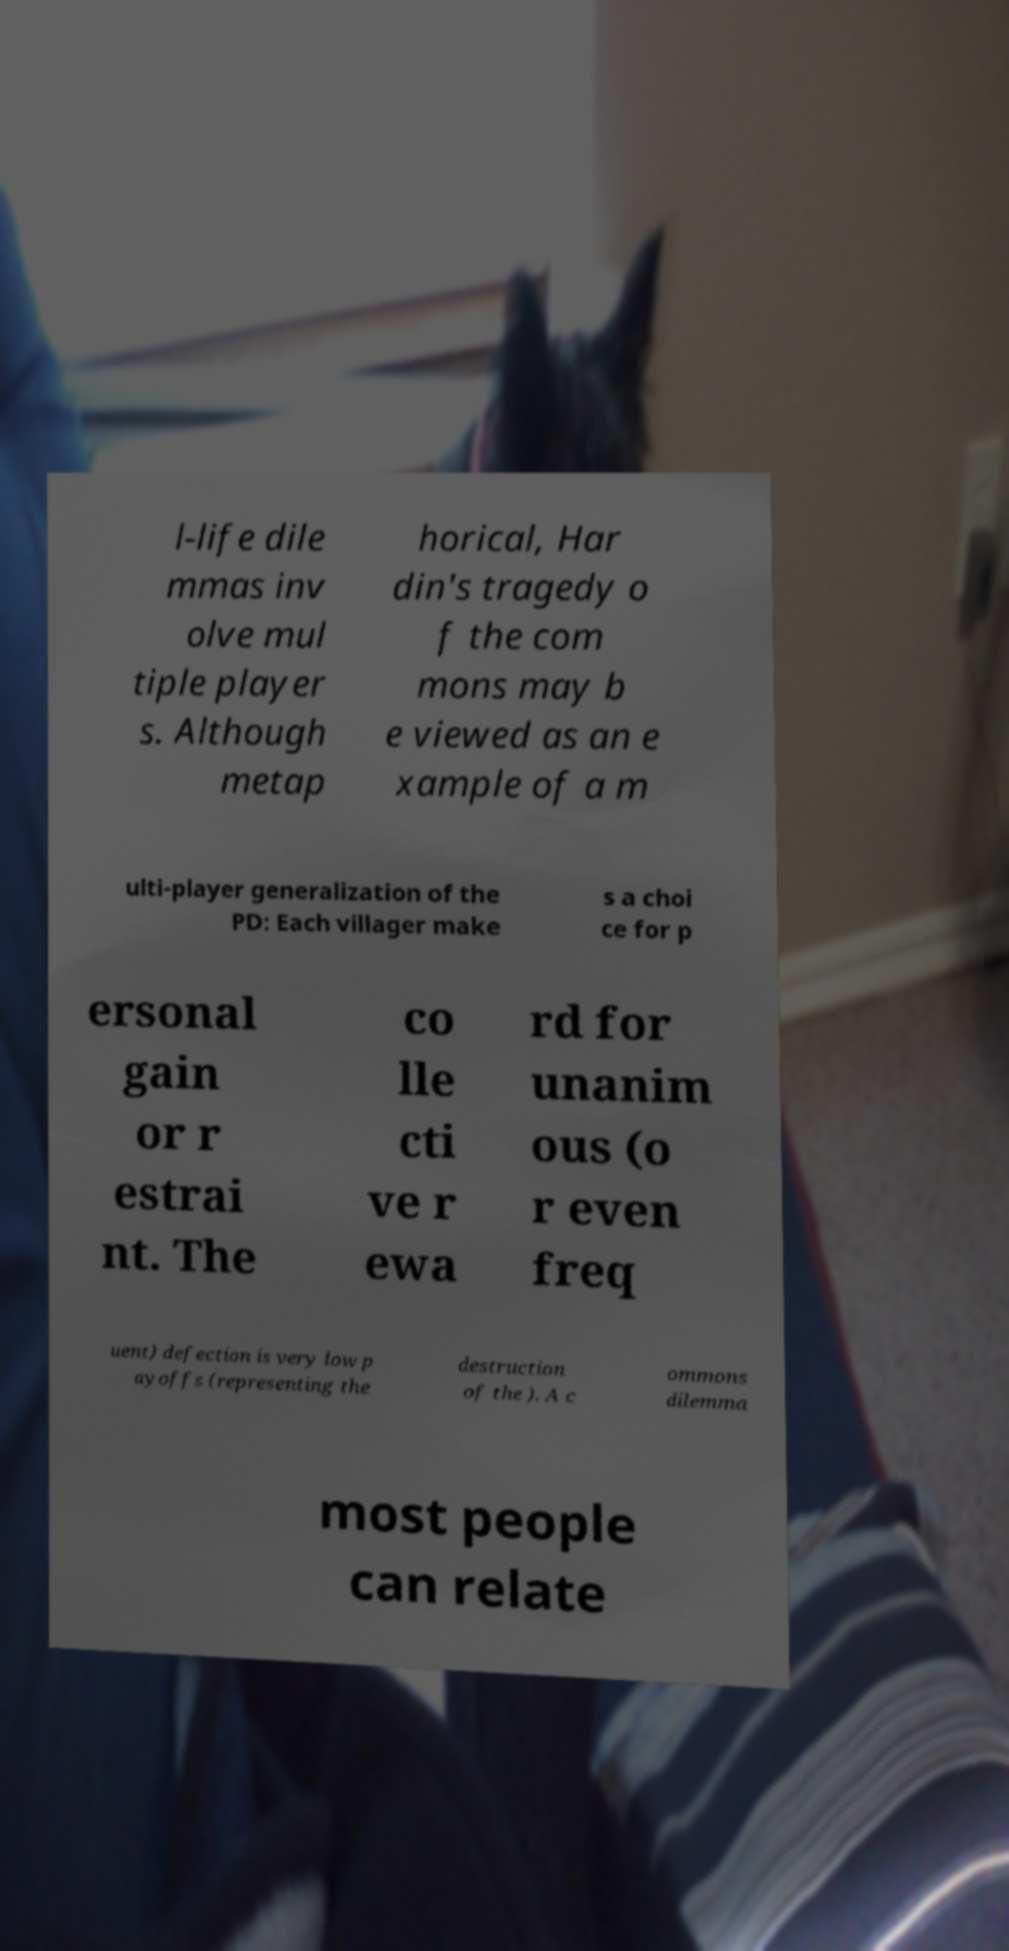Please read and relay the text visible in this image. What does it say? l-life dile mmas inv olve mul tiple player s. Although metap horical, Har din's tragedy o f the com mons may b e viewed as an e xample of a m ulti-player generalization of the PD: Each villager make s a choi ce for p ersonal gain or r estrai nt. The co lle cti ve r ewa rd for unanim ous (o r even freq uent) defection is very low p ayoffs (representing the destruction of the ). A c ommons dilemma most people can relate 